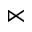Convert formula to latex. <formula><loc_0><loc_0><loc_500><loc_500>\ltimes</formula> 